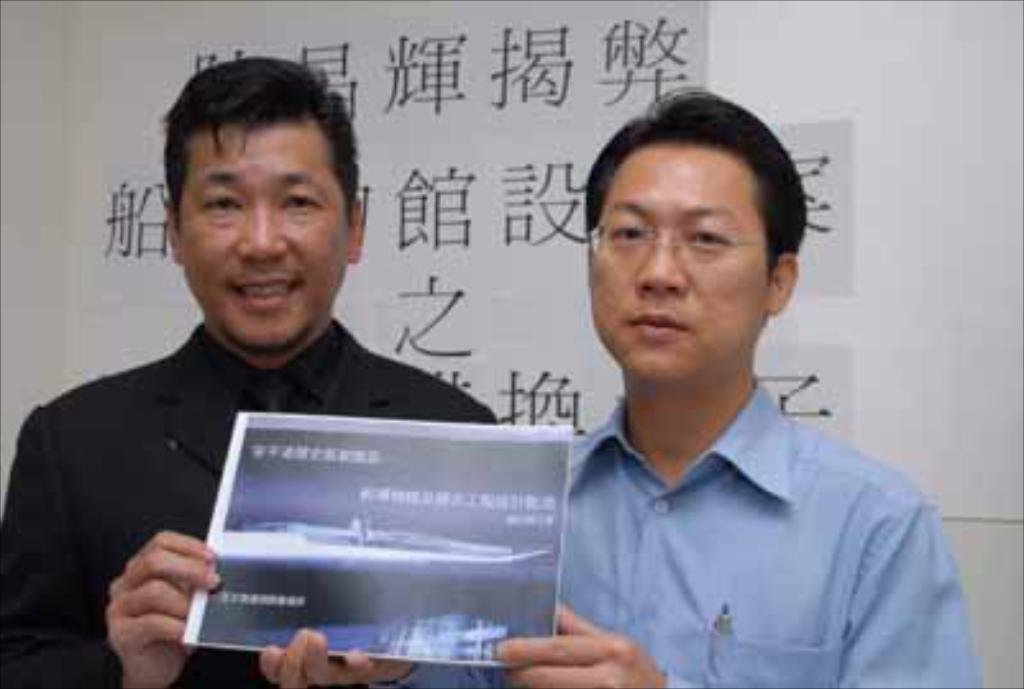How many people are in the image? There are two persons in the image. What are the two persons doing in the image? The two persons are holding an object. Can you identify any specific objects in the image? Yes, there is a pen in the image. What is visible behind the people in the image? There is some text visible behind the people. What type of bird can be seen flying in the image? There is no bird visible in the image. How does the son contribute to the scene in the image? The provided facts do not mention a son or any familial relationship between the two persons in the image. 